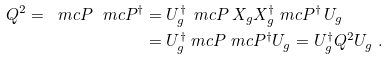<formula> <loc_0><loc_0><loc_500><loc_500>Q ^ { 2 } = \ m c P \ m c P ^ { \dagger } & = U _ { g } ^ { \dagger } \, \ m c P \, X _ { g } X _ { g } ^ { \dagger } \ m c P ^ { \dagger } \, U _ { g } \\ & = U _ { g } ^ { \dagger } \ m c P \ m c P ^ { \dagger } U _ { g } = U _ { g } ^ { \dagger } Q ^ { 2 } U _ { g } \ .</formula> 